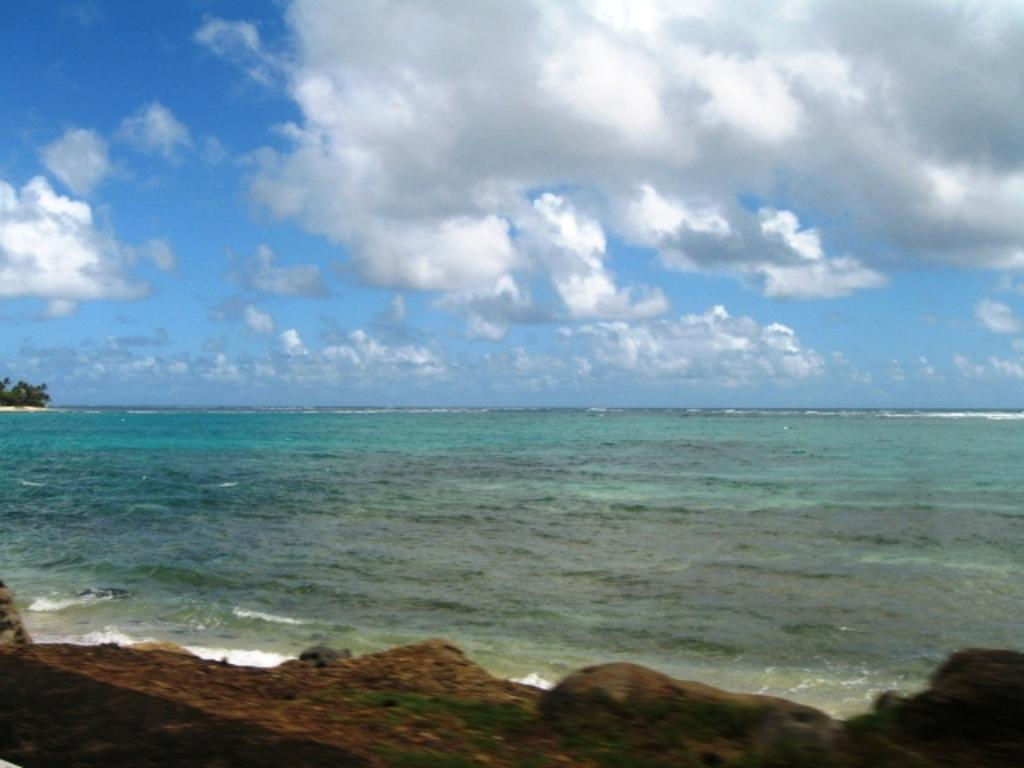What is visible in the image? Water is visible in the image. What can be seen in the background of the image? Clouds and the sky are visible in the background of the image. What type of vegetation is present in the image? There are trees in the image. What type of gun can be seen in the aftermath of the power outage in the image? There is no gun or power outage present in the image; it features water, clouds, sky, and trees. 